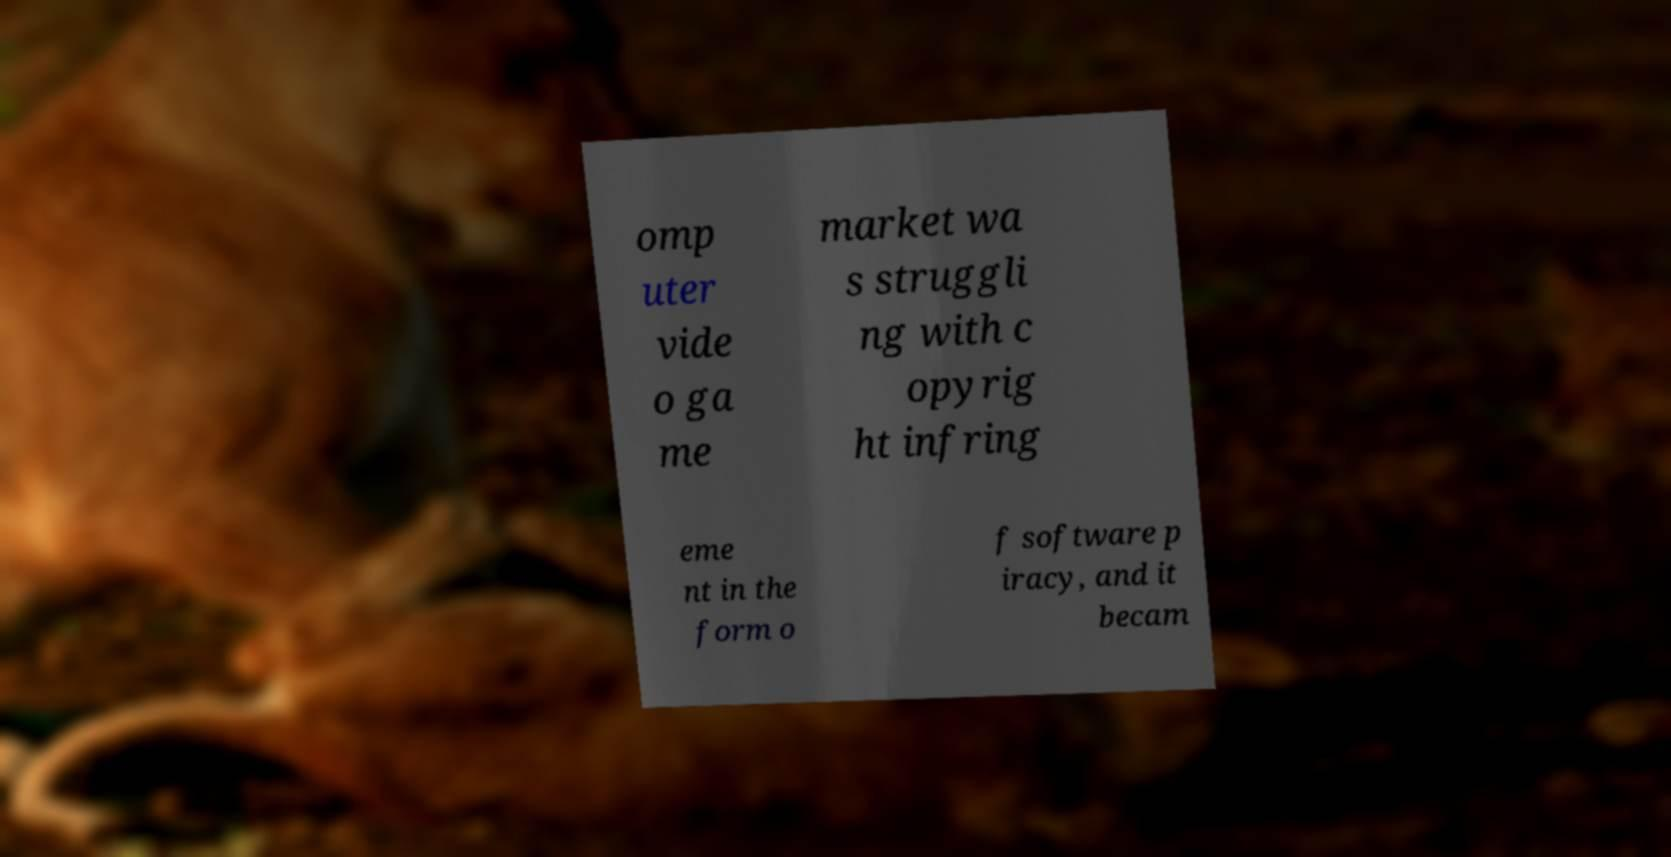I need the written content from this picture converted into text. Can you do that? omp uter vide o ga me market wa s struggli ng with c opyrig ht infring eme nt in the form o f software p iracy, and it becam 